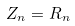<formula> <loc_0><loc_0><loc_500><loc_500>Z _ { n } = R _ { n }</formula> 